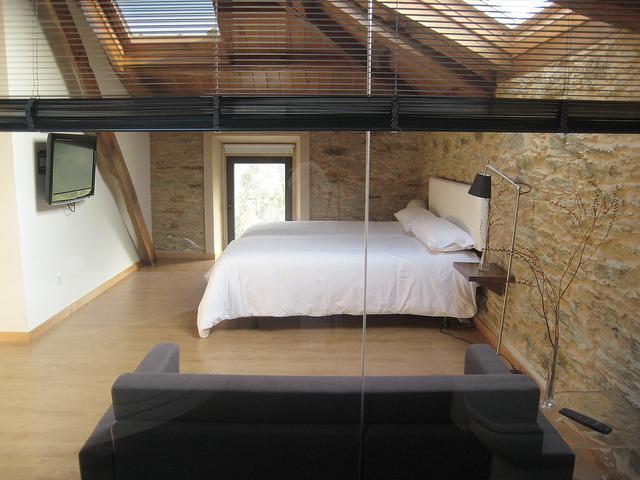How many horses with a white stomach are there?
Give a very brief answer. 0. 